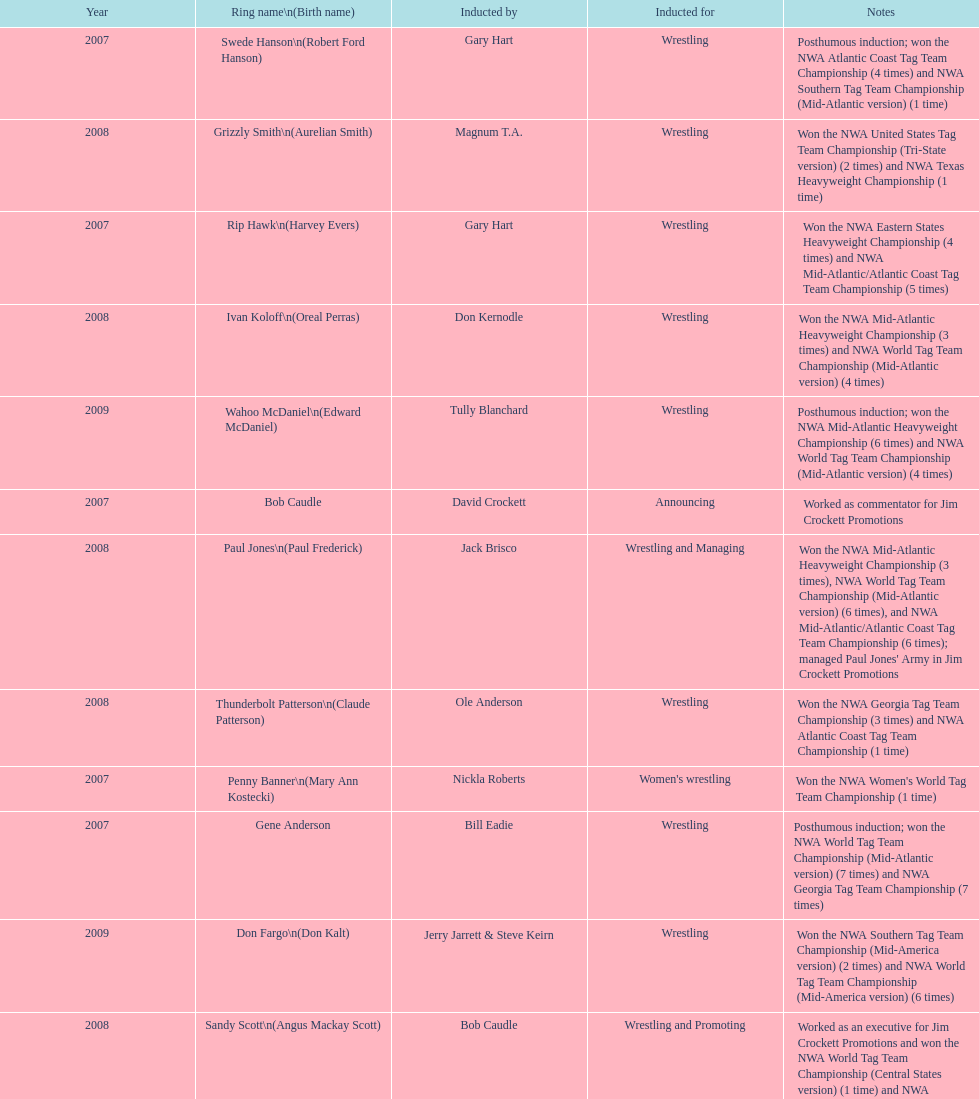Who joined after royal's induction? Lance Russell. 